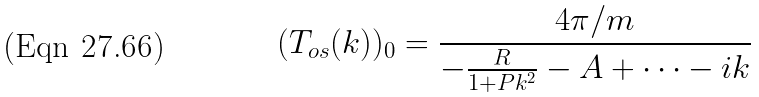<formula> <loc_0><loc_0><loc_500><loc_500>( T _ { o s } ( k ) ) _ { 0 } = \frac { 4 \pi / m } { - \frac { R } { 1 + P k ^ { 2 } } - A + \dots - i k }</formula> 